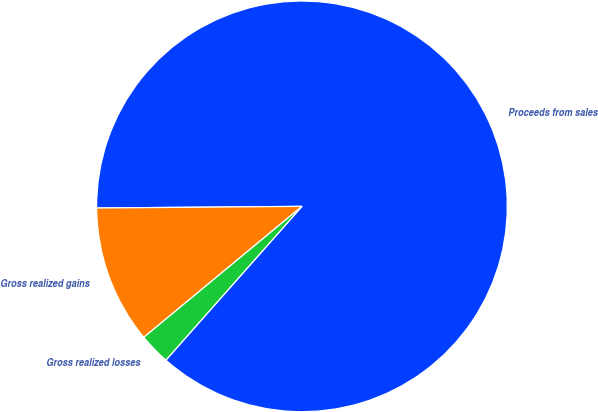Convert chart to OTSL. <chart><loc_0><loc_0><loc_500><loc_500><pie_chart><fcel>Proceeds from sales<fcel>Gross realized gains<fcel>Gross realized losses<nl><fcel>86.65%<fcel>10.88%<fcel>2.46%<nl></chart> 